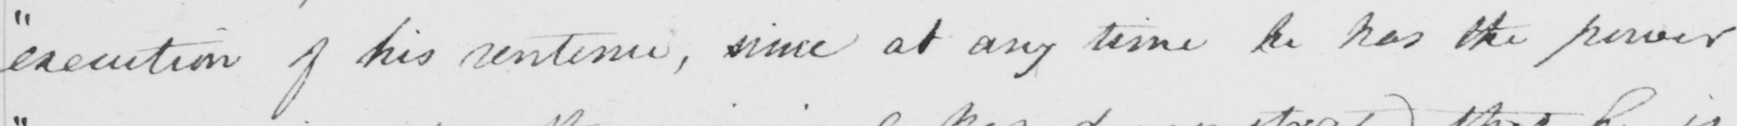What is written in this line of handwriting? " execution of his sentence , since at any time he has the power 